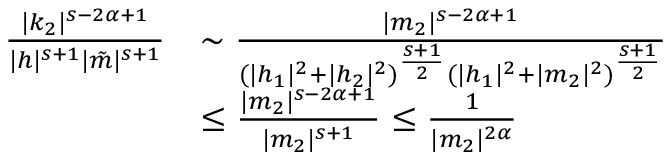Convert formula to latex. <formula><loc_0><loc_0><loc_500><loc_500>\begin{array} { r l } { \frac { | k _ { 2 } | ^ { s - 2 \alpha + 1 } } { | h | ^ { s + 1 } | \tilde { m } | ^ { s + 1 } } } & { \sim \frac { | m _ { 2 } | ^ { s - 2 \alpha + 1 } } { ( | h _ { 1 } | ^ { 2 } + | h _ { 2 } | ^ { 2 } ) ^ { \frac { s + 1 } { 2 } } ( | h _ { 1 } | ^ { 2 } + | m _ { 2 } | ^ { 2 } ) ^ { \frac { s + 1 } { 2 } } } } \\ & { \leq \frac { | m _ { 2 } | ^ { s - 2 \alpha + 1 } } { | m _ { 2 } | ^ { s + 1 } } \leq \frac { 1 } { | m _ { 2 } | ^ { 2 \alpha } } } \end{array}</formula> 